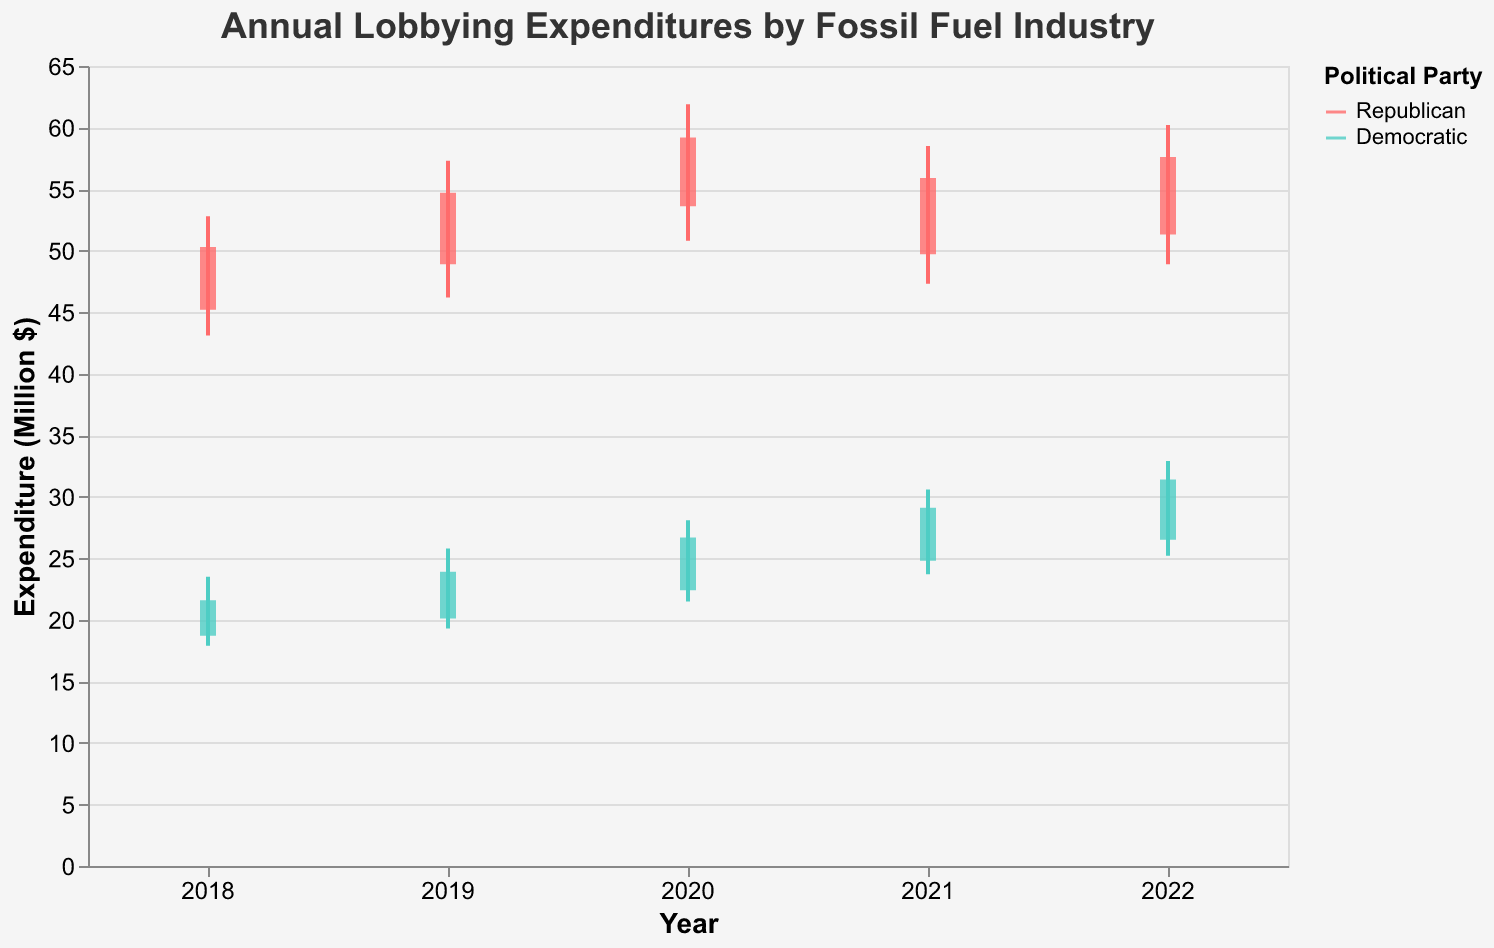What is the highest lobbying expenditure by the Republican Party in 2020? The figure shows the annual lobbying expenditures by the fossil fuel industry, broken down by political party. For 2020, looking at the expenditure labeled "High," the highest amount for Republicans is given.
Answer: $61.9 million What was the opening expenditure for the Democratic Party in 2018? The figure shows the annual opening expenditures by the fossil fuel industry broken down by political party. For 2018, the opening expenditure for Democrats is provided.
Answer: $18.7 million Which year had the lowest closing expenditure for the Democratic Party? To find the lowest closing expenditure for Democrats, one must look at the "Close" values for each year associated with the Democratic Party and compare them. The year with the smallest value is the correct answer.
Answer: 2018 What is the difference between the highest and lowest expenditures for the Republican Party in 2022? For 2022, look at the "High" and "Low" expenditures for Republicans. Subtract the lowest value from the highest to get the difference: $60.2 million - $48.9 million = $11.3 million.
Answer: $11.3 million On average, how much did the Democratic Party’s closing expenditure increase per year between 2018 and 2022? Calculate the closing expenditure increase year-over-year for Democrats and then average these to find the average annual increase. (2019: $23.9 million - $21.6 million = $2.3 million, 2020: $26.7 million - $23.9 million = $2.8 million, 2021: $29.1 million - $26.7 million = $2.4 million, and 2022: $31.4 million - $29.1 million = $2.3 million. Then, (2.3 + 2.8 + 2.4 + 2.3) / 4 = 2.45.)
Answer: $2.45 million Which party had a larger increase in their closing expenditures from 2018 to 2022, and by how much? Calculate the change in closing expenditure for both parties from 2018 to 2022. For Republicans: $57.6 million - $50.3 million = $7.3 million. For Democrats: $31.4 million - $21.6 million = $9.8 million. Compare the two increases to determine which is larger.
Answer: Democratic Party by $2.5 million What was the average high expenditure for the Republican Party over the five years? Add the high expenditures for Republicans from 2018 to 2022 and divide by the number of years: ($52.8 million + $57.3 million + $61.9 million + $58.5 million + $60.2 million) / 5 = $58.14 million.
Answer: $58.14 million In which year did the Democratic Party see their highest low expenditure? Examine the "Low" values for the Democratic Party from each year and identify the highest one. The year corresponding to this value is the correct answer.
Answer: 2022 